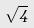Convert formula to latex. <formula><loc_0><loc_0><loc_500><loc_500>\sqrt { 4 }</formula> 